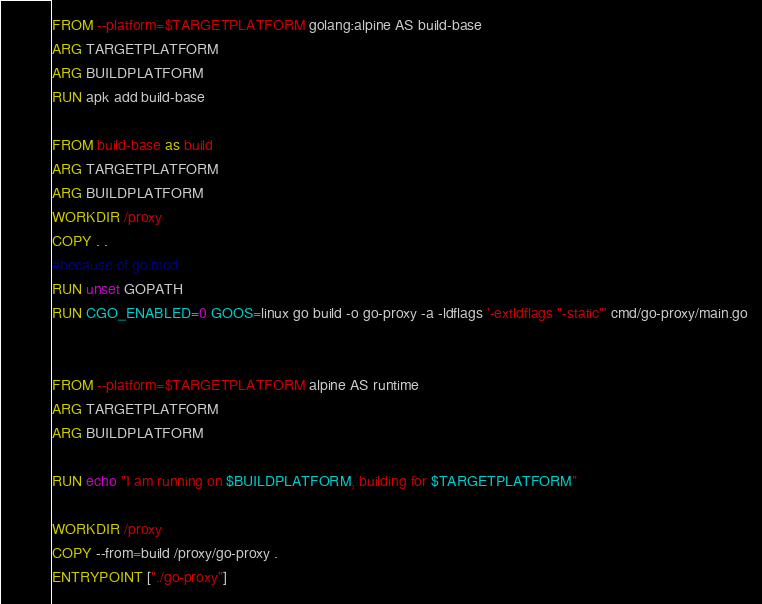Convert code to text. <code><loc_0><loc_0><loc_500><loc_500><_Dockerfile_>FROM --platform=$TARGETPLATFORM golang:alpine AS build-base
ARG TARGETPLATFORM
ARG BUILDPLATFORM
RUN apk add build-base

FROM build-base as build
ARG TARGETPLATFORM
ARG BUILDPLATFORM
WORKDIR /proxy
COPY . .
#because of go.mod
RUN unset GOPATH
RUN CGO_ENABLED=0 GOOS=linux go build -o go-proxy -a -ldflags '-extldflags "-static"' cmd/go-proxy/main.go


FROM --platform=$TARGETPLATFORM alpine AS runtime
ARG TARGETPLATFORM
ARG BUILDPLATFORM

RUN echo "I am running on $BUILDPLATFORM, building for $TARGETPLATFORM"

WORKDIR /proxy
COPY --from=build /proxy/go-proxy .
ENTRYPOINT ["./go-proxy"]</code> 